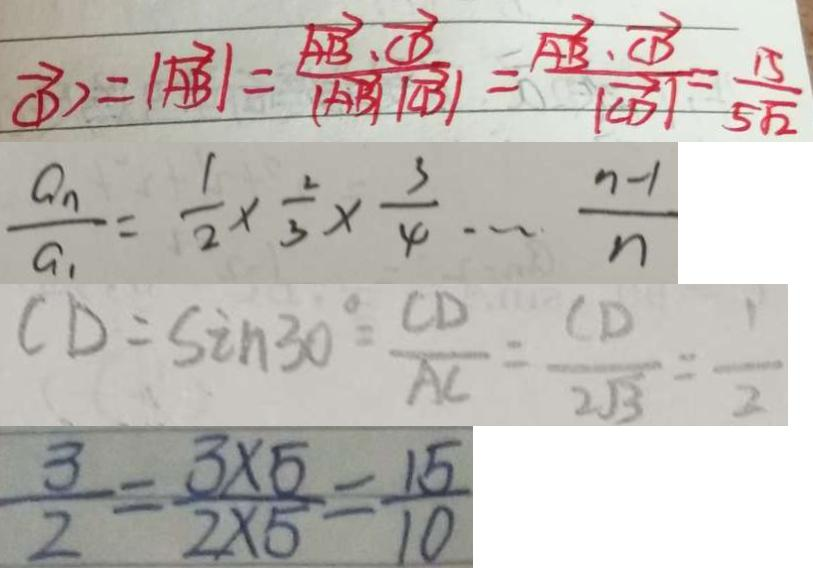<formula> <loc_0><loc_0><loc_500><loc_500>\overrightarrow { C D } > = \vert \overrightarrow { A B } \vert = \frac { \overrightarrow { A B } \cdot \overrightarrow { C D } } { \vert \overrightarrow { A B } / / \overrightarrow { C B } \vert } = \frac { \overrightarrow { A B } \cdot \overrightarrow { C D } } { \vert \overrightarrow { C D } \vert } = \frac { 1 5 } { 5 \sqrt { 2 } } 
 \frac { a _ { n } } { a _ { 1 } } = \frac { 1 } { 2 } \times \frac { 2 } { 3 } \times \frac { 3 } { 4 } \cdots \frac { n - 1 } { n } 
 C D = \sin 3 0 ^ { \circ } = \frac { C D } { A C } = \frac { C D } { 2 \sqrt { 3 } } = \frac { 1 } { 2 } 
 \frac { 3 } { 2 } = \frac { 3 \times 5 } { 2 \times 5 } = \frac { 1 5 } { 1 0 }</formula> 